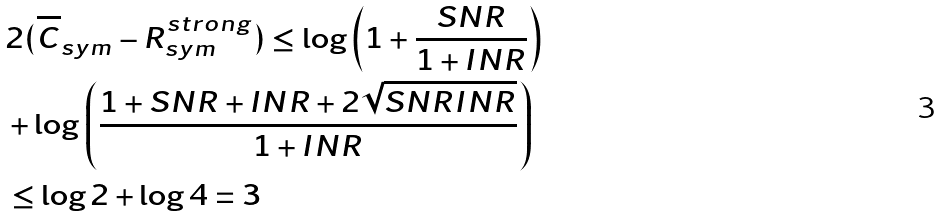<formula> <loc_0><loc_0><loc_500><loc_500>& 2 ( \overline { C } _ { s y m } - R _ { s y m } ^ { s t r o n g } ) \leq \log \left ( 1 + \frac { S N R } { 1 + I N R } \right ) \\ & + \log \left ( \frac { 1 + S N R + I N R + 2 \sqrt { S N R I N R } } { 1 + I N R } \right ) \\ & \leq \log 2 + \log 4 = 3</formula> 